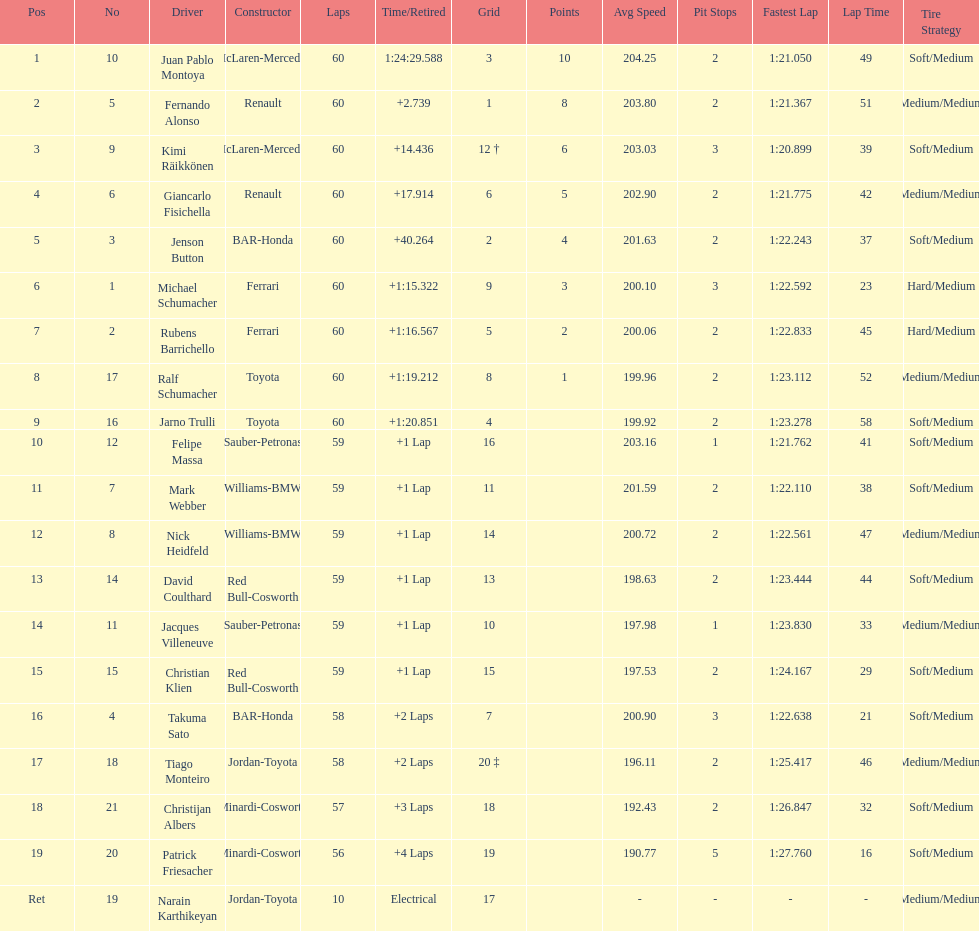How many drivers from germany? 3. 